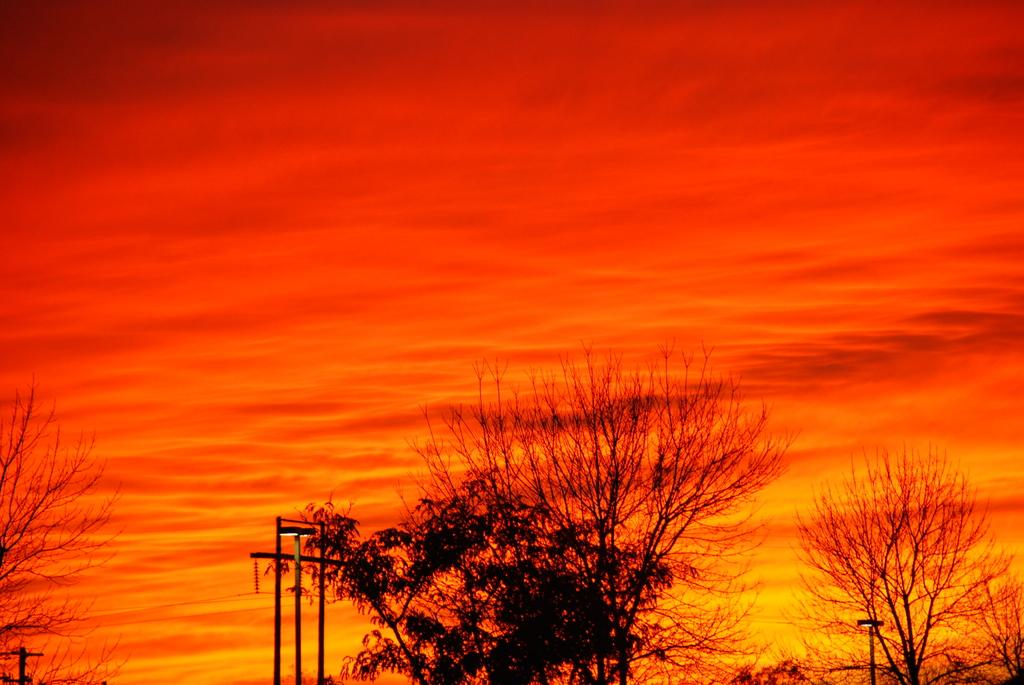What type of natural elements can be seen in the image? There are trees in the image. What man-made structures are present in the image? There are power poles in the image. What part of the natural environment is visible in the image? The sky is visible in the image. What is the color of the sky in the image? The sky has an orange color in the image. Where is the cub located in the image? There is no cub present in the image. What type of mine can be seen in the image? There is no mine present in the image. 